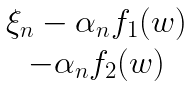<formula> <loc_0><loc_0><loc_500><loc_500>\begin{matrix} \xi _ { n } - \alpha _ { n } f _ { 1 } ( w ) \\ - \alpha _ { n } f _ { 2 } ( w ) \end{matrix}</formula> 